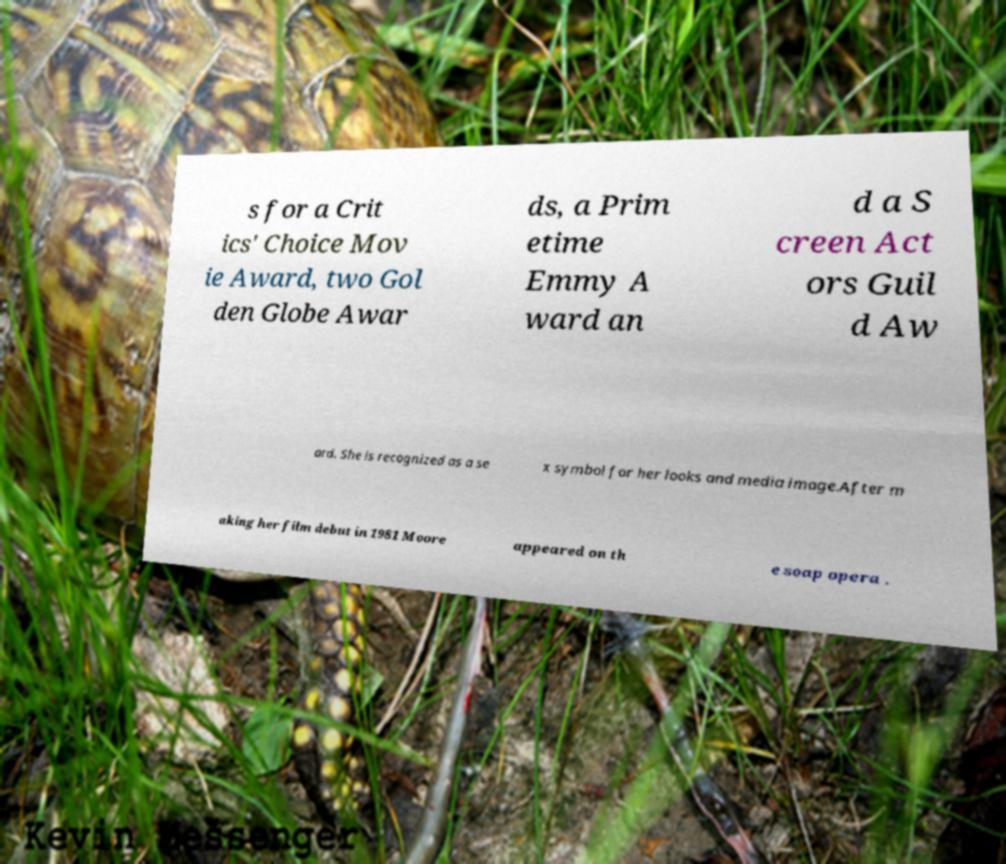Can you read and provide the text displayed in the image?This photo seems to have some interesting text. Can you extract and type it out for me? s for a Crit ics' Choice Mov ie Award, two Gol den Globe Awar ds, a Prim etime Emmy A ward an d a S creen Act ors Guil d Aw ard. She is recognized as a se x symbol for her looks and media image.After m aking her film debut in 1981 Moore appeared on th e soap opera . 